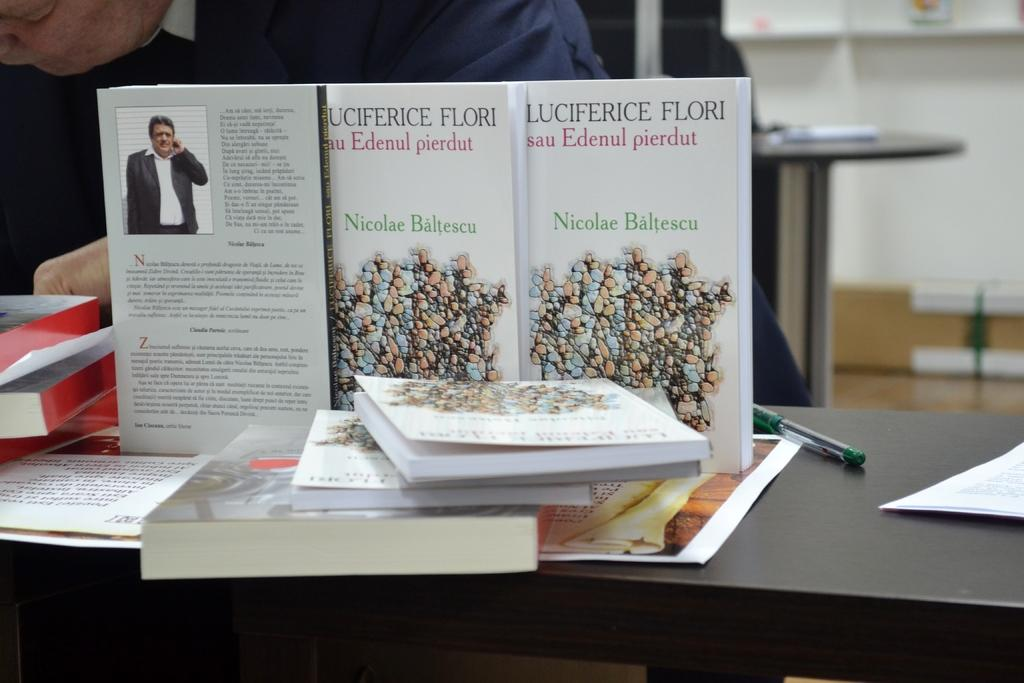<image>
Write a terse but informative summary of the picture. Nicolae Baltescu wrote the book Luciferice Flori sau Edenul pierdut. 